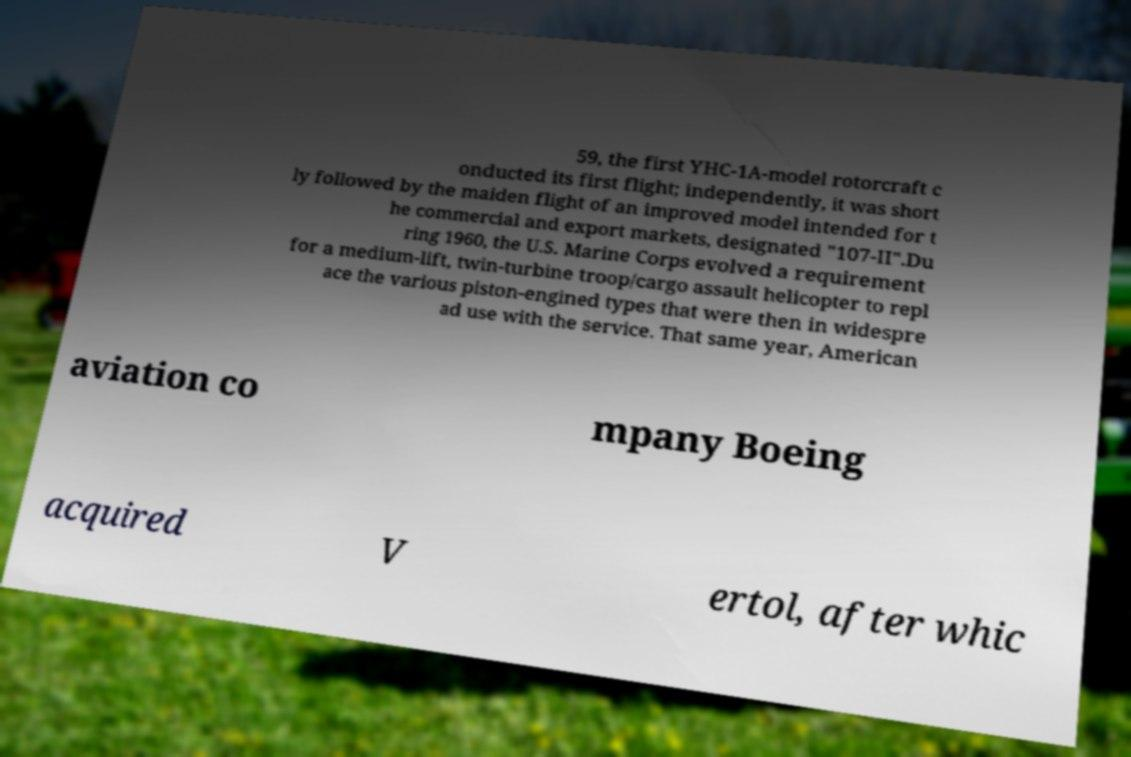Please identify and transcribe the text found in this image. 59, the first YHC-1A-model rotorcraft c onducted its first flight; independently, it was short ly followed by the maiden flight of an improved model intended for t he commercial and export markets, designated "107-II".Du ring 1960, the U.S. Marine Corps evolved a requirement for a medium-lift, twin-turbine troop/cargo assault helicopter to repl ace the various piston-engined types that were then in widespre ad use with the service. That same year, American aviation co mpany Boeing acquired V ertol, after whic 